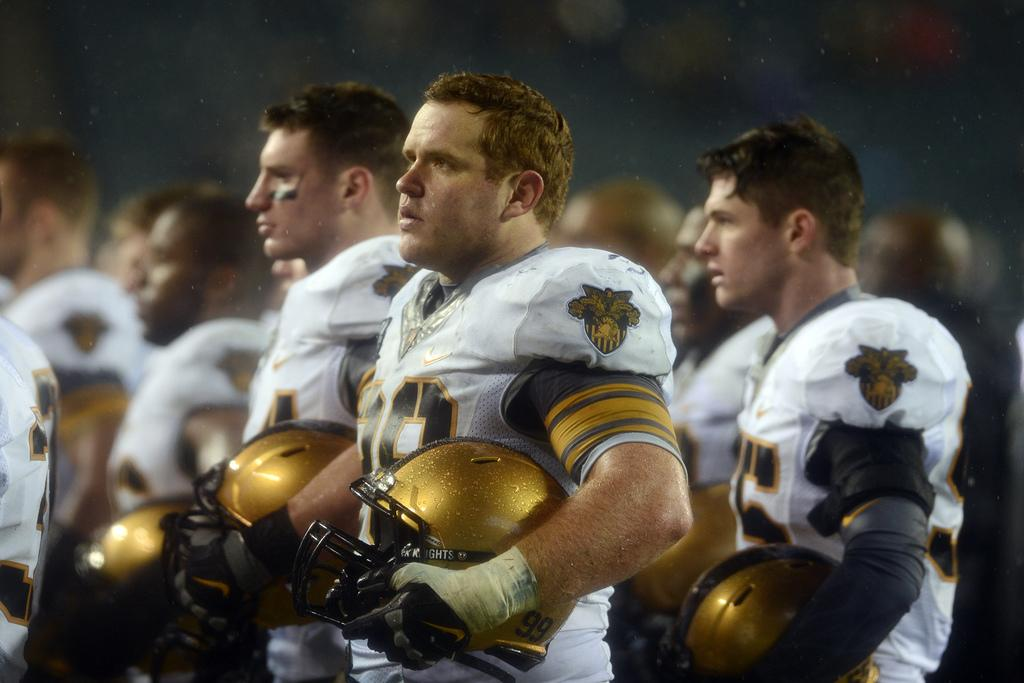What is the main subject of the image? The main subject of the image is a group of persons. What are the persons wearing in the image? The persons are wearing white color dresses. What are the persons holding in the image? The persons are holding helmets. What are the persons doing in the image? The persons are standing. Can you describe the background of the image? There is a group of persons in the background of the image, and there are other objects visible as well. What type of hospital equipment can be seen in the image? There is no hospital equipment present in the image. What type of waste is visible in the image? There is no waste visible in the image. 